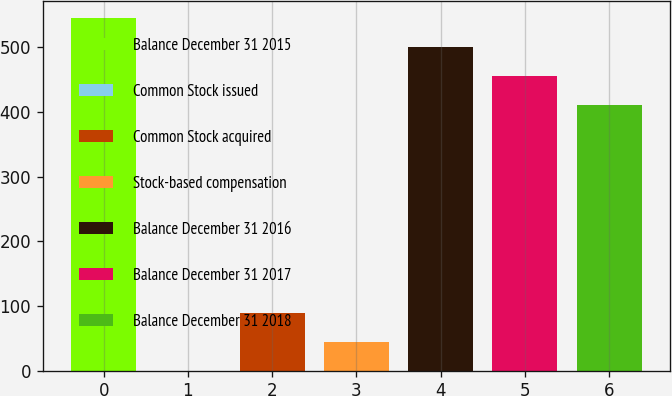<chart> <loc_0><loc_0><loc_500><loc_500><bar_chart><fcel>Balance December 31 2015<fcel>Common Stock issued<fcel>Common Stock acquired<fcel>Stock-based compensation<fcel>Balance December 31 2016<fcel>Balance December 31 2017<fcel>Balance December 31 2018<nl><fcel>544.77<fcel>0.16<fcel>89.54<fcel>44.85<fcel>500.08<fcel>455.39<fcel>410.7<nl></chart> 